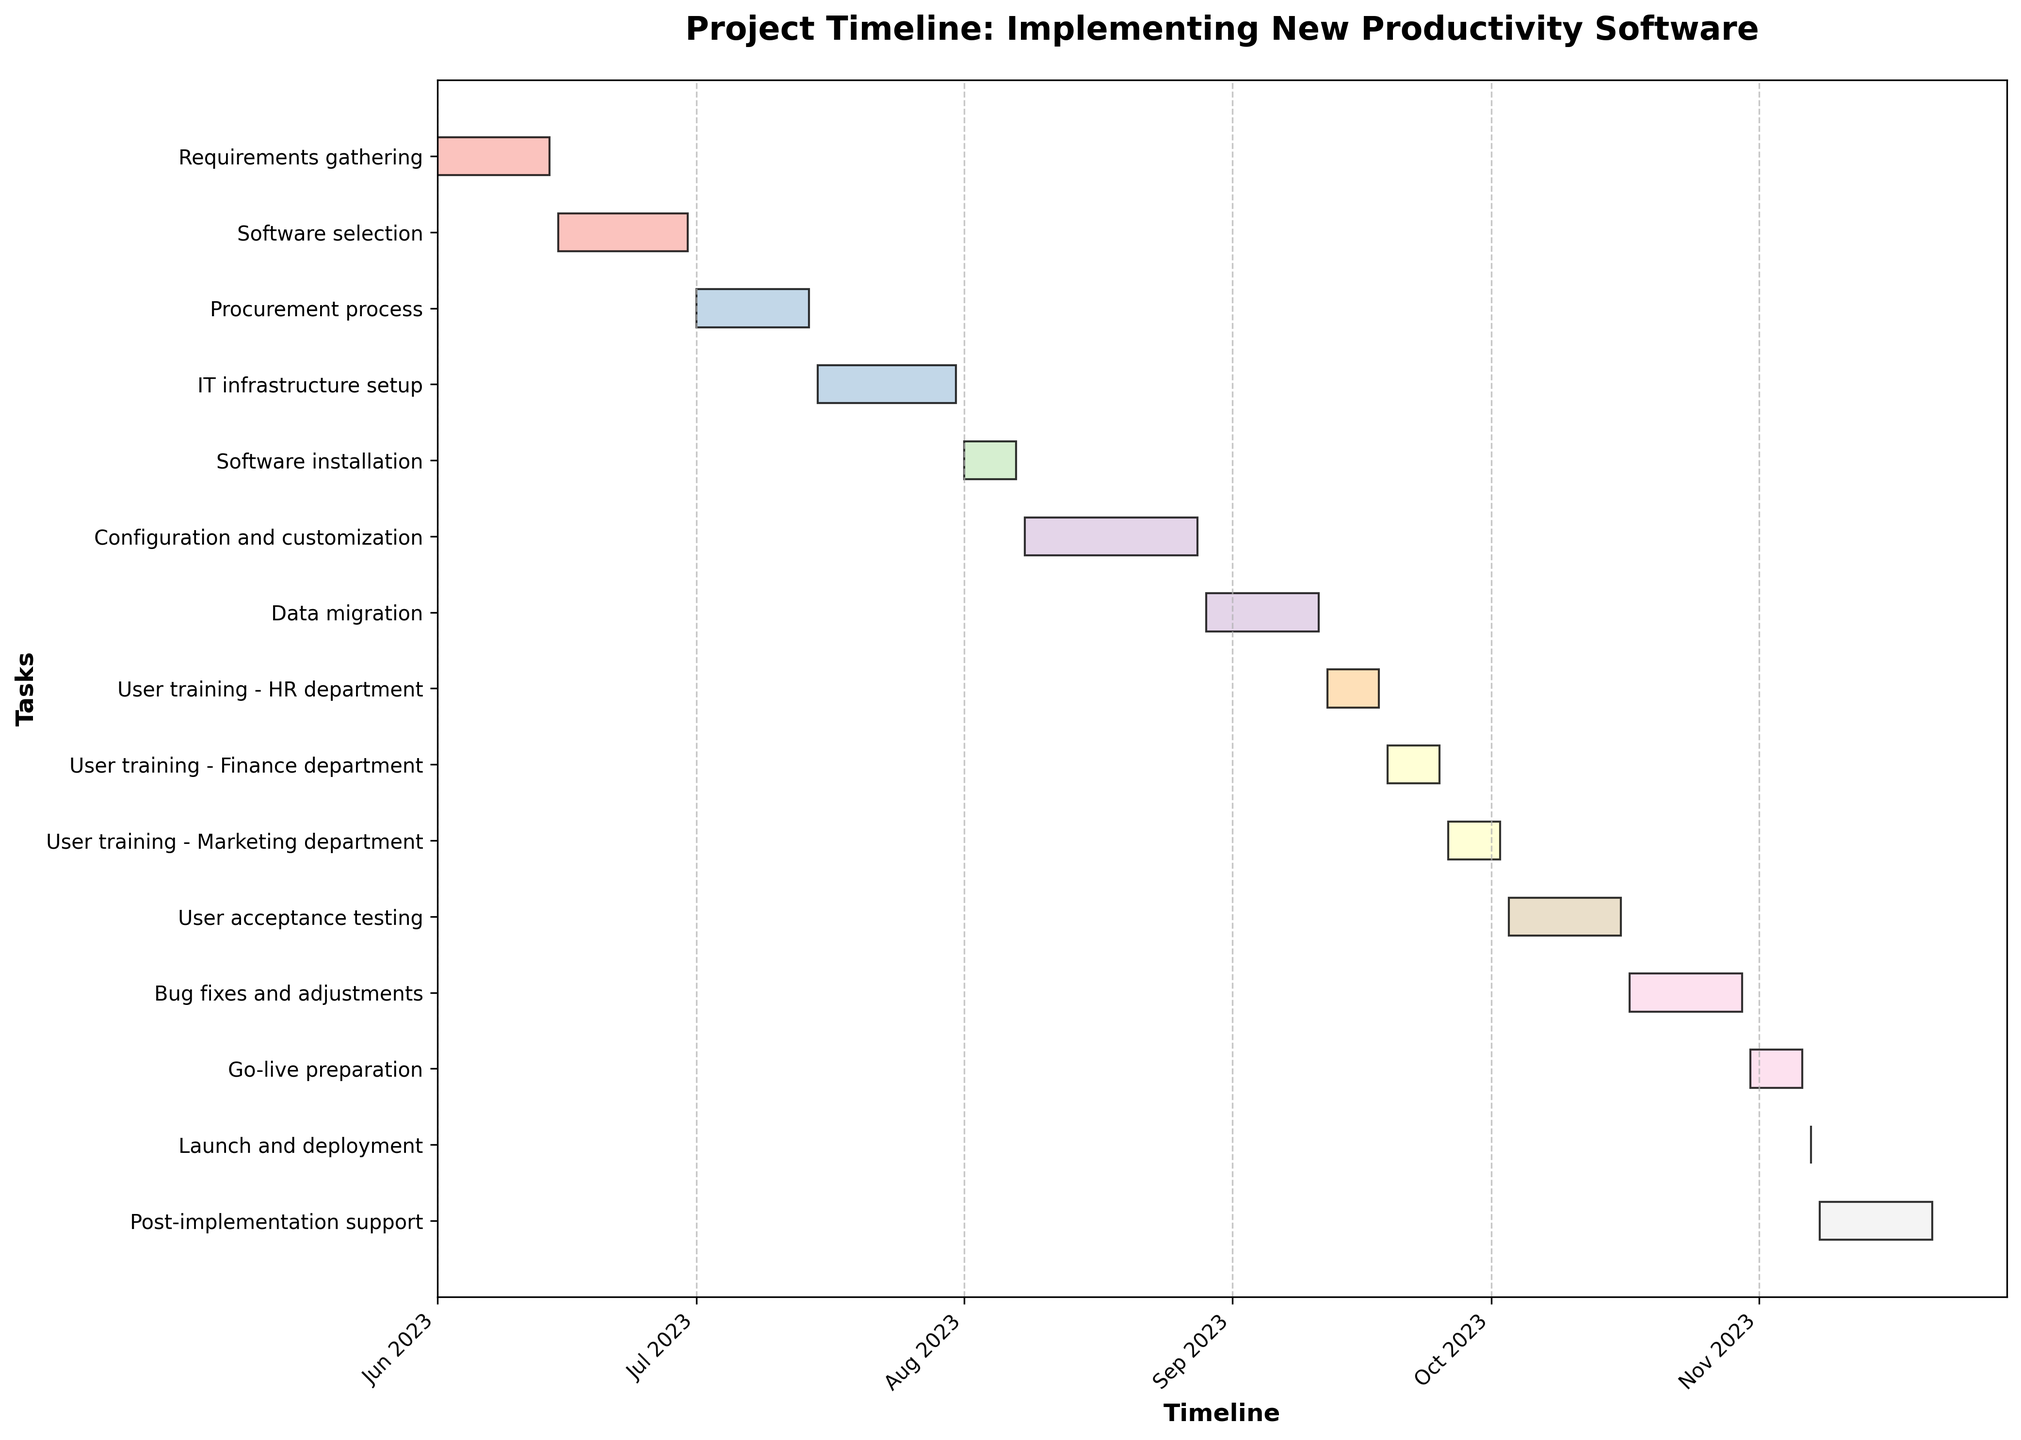What's the title of the Gantt Chart? The title is located at the top center of the chart in bold font, and it usually serves as an entry point for understanding the overall purpose of the chart. By looking at the center-top area of the figure, you will see that the title is "Project Timeline: Implementing New Productivity Software".
Answer: Project Timeline: Implementing New Productivity Software How many tasks are involved in the project? By counting the number of horizontal bars (each bar represents a task) shown on the y-axis, you should be able to tally the total tasks. There are 15 tasks listed from "Requirements gathering" to "Post-implementation support".
Answer: 15 What is the duration of the "Configuration and Customization" task in days? Identify the horizontal bar labeled "Configuration and Customization" on the y-axis, then observe the length of this bar as indicated on the x-axis. The task is labeled as starting on 2023-08-08 and ending on 2023-08-28, making its total duration 21 days.
Answer: 21 days Which task has the shortest duration, and how long is it? Find the task with the shortest horizontal bar on the plot. The "Launch and deployment" task is the shortest with a duration of just one day, starting and ending on 2023-11-07.
Answer: Launch and deployment, 1 day How does the duration of "Software Selection" compare with "Procurement Process"? Identify both tasks on the y-axis, compare their horizontal bars, and note their duration. "Software Selection" has a length covering 16 days while "Procurement Process" spans 14 days. Comparing both, "Software Selection" is 2 days longer than "Procurement Process".
Answer: Software Selection is 2 days longer When does the "Go-live Preparation" task begin and end? Locate the "Go-live Preparation" task on the y-axis and examine the start and end points on the x-axis. "Go-live Preparation" begins on 2023-10-31 and ends on 2023-11-06.
Answer: 2023-10-31 to 2023-11-06 What's the cumulative length in days for all the "User Training" tasks? Add the durations of all "User Training" tasks marked on the y-axis: HR Department (7 days), Finance Department (7 days), Marketing Department (7 days). Summing them up: 7 + 7 + 7 = 21 days.
Answer: 21 days Which phase takes place immediately before "User Acceptance Testing"? Find "User Acceptance Testing" (October 3-16, 2023) on the y-axis and trace the preceding task upwards on the same axis. The previous phase is "User Training - Marketing Department" (September 26 - October 2, 2023).
Answer: User Training - Marketing Department What is the total duration of the project from start to end date? Identify the start date of the earliest task ("Requirements gathering" on June 1, 2023) and the end date of the latest task ("Post-implementation support" on November 21, 2023). Calculate the number of days between these two dates. Starting from June 1 to November 21 includes 174 days in total.
Answer: 174 days How many tasks are scheduled to last for exactly 14 days? By referencing the duration column or inspecting the length of the bars directly on the figure and counting, you can identify the tasks with a 14-day duration. The tasks are "Requirements gathering," "Procurement process," "Data migration," "User acceptance testing," "Bug fixes and adjustments," and "Post-implementation support," totaling 6.
Answer: 6 